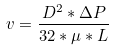Convert formula to latex. <formula><loc_0><loc_0><loc_500><loc_500>v = \frac { D ^ { 2 } * \Delta P } { 3 2 * \mu * L }</formula> 